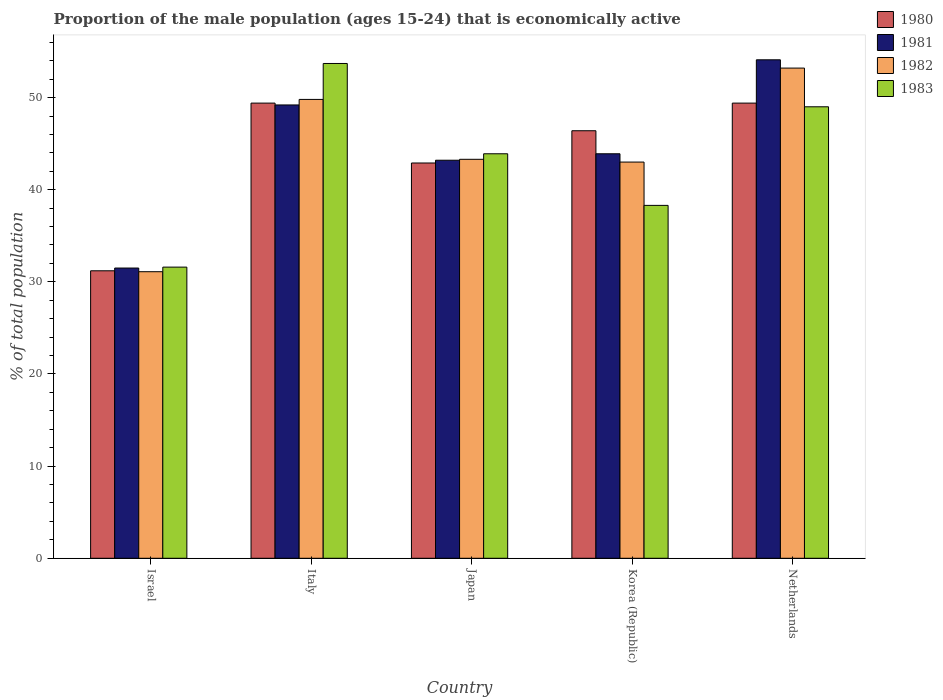Are the number of bars per tick equal to the number of legend labels?
Make the answer very short. Yes. How many bars are there on the 3rd tick from the right?
Offer a terse response. 4. In how many cases, is the number of bars for a given country not equal to the number of legend labels?
Your answer should be compact. 0. What is the proportion of the male population that is economically active in 1980 in Netherlands?
Ensure brevity in your answer.  49.4. Across all countries, what is the maximum proportion of the male population that is economically active in 1982?
Keep it short and to the point. 53.2. Across all countries, what is the minimum proportion of the male population that is economically active in 1981?
Provide a succinct answer. 31.5. In which country was the proportion of the male population that is economically active in 1982 minimum?
Give a very brief answer. Israel. What is the total proportion of the male population that is economically active in 1982 in the graph?
Provide a succinct answer. 220.4. What is the difference between the proportion of the male population that is economically active in 1981 in Israel and that in Japan?
Your answer should be very brief. -11.7. What is the difference between the proportion of the male population that is economically active in 1982 in Israel and the proportion of the male population that is economically active in 1981 in Netherlands?
Your answer should be compact. -23. What is the average proportion of the male population that is economically active in 1980 per country?
Ensure brevity in your answer.  43.86. What is the difference between the proportion of the male population that is economically active of/in 1981 and proportion of the male population that is economically active of/in 1980 in Italy?
Keep it short and to the point. -0.2. What is the ratio of the proportion of the male population that is economically active in 1982 in Japan to that in Netherlands?
Your response must be concise. 0.81. What is the difference between the highest and the second highest proportion of the male population that is economically active in 1982?
Offer a terse response. 6.5. What is the difference between the highest and the lowest proportion of the male population that is economically active in 1980?
Offer a terse response. 18.2. In how many countries, is the proportion of the male population that is economically active in 1981 greater than the average proportion of the male population that is economically active in 1981 taken over all countries?
Your answer should be very brief. 2. What does the 2nd bar from the right in Israel represents?
Provide a short and direct response. 1982. Is it the case that in every country, the sum of the proportion of the male population that is economically active in 1982 and proportion of the male population that is economically active in 1980 is greater than the proportion of the male population that is economically active in 1983?
Give a very brief answer. Yes. How many bars are there?
Provide a succinct answer. 20. Are all the bars in the graph horizontal?
Offer a very short reply. No. Does the graph contain any zero values?
Your answer should be very brief. No. Where does the legend appear in the graph?
Provide a succinct answer. Top right. How many legend labels are there?
Give a very brief answer. 4. What is the title of the graph?
Give a very brief answer. Proportion of the male population (ages 15-24) that is economically active. What is the label or title of the X-axis?
Your answer should be very brief. Country. What is the label or title of the Y-axis?
Your answer should be very brief. % of total population. What is the % of total population in 1980 in Israel?
Provide a succinct answer. 31.2. What is the % of total population in 1981 in Israel?
Make the answer very short. 31.5. What is the % of total population in 1982 in Israel?
Give a very brief answer. 31.1. What is the % of total population in 1983 in Israel?
Your answer should be compact. 31.6. What is the % of total population in 1980 in Italy?
Offer a very short reply. 49.4. What is the % of total population in 1981 in Italy?
Make the answer very short. 49.2. What is the % of total population in 1982 in Italy?
Keep it short and to the point. 49.8. What is the % of total population of 1983 in Italy?
Provide a short and direct response. 53.7. What is the % of total population in 1980 in Japan?
Offer a terse response. 42.9. What is the % of total population of 1981 in Japan?
Ensure brevity in your answer.  43.2. What is the % of total population in 1982 in Japan?
Give a very brief answer. 43.3. What is the % of total population of 1983 in Japan?
Ensure brevity in your answer.  43.9. What is the % of total population of 1980 in Korea (Republic)?
Provide a short and direct response. 46.4. What is the % of total population of 1981 in Korea (Republic)?
Your response must be concise. 43.9. What is the % of total population in 1982 in Korea (Republic)?
Provide a succinct answer. 43. What is the % of total population in 1983 in Korea (Republic)?
Your answer should be very brief. 38.3. What is the % of total population in 1980 in Netherlands?
Make the answer very short. 49.4. What is the % of total population in 1981 in Netherlands?
Give a very brief answer. 54.1. What is the % of total population in 1982 in Netherlands?
Ensure brevity in your answer.  53.2. Across all countries, what is the maximum % of total population of 1980?
Your answer should be compact. 49.4. Across all countries, what is the maximum % of total population of 1981?
Your answer should be very brief. 54.1. Across all countries, what is the maximum % of total population in 1982?
Your response must be concise. 53.2. Across all countries, what is the maximum % of total population of 1983?
Your answer should be compact. 53.7. Across all countries, what is the minimum % of total population of 1980?
Your response must be concise. 31.2. Across all countries, what is the minimum % of total population in 1981?
Offer a very short reply. 31.5. Across all countries, what is the minimum % of total population of 1982?
Your response must be concise. 31.1. Across all countries, what is the minimum % of total population of 1983?
Make the answer very short. 31.6. What is the total % of total population in 1980 in the graph?
Give a very brief answer. 219.3. What is the total % of total population of 1981 in the graph?
Ensure brevity in your answer.  221.9. What is the total % of total population of 1982 in the graph?
Ensure brevity in your answer.  220.4. What is the total % of total population in 1983 in the graph?
Offer a terse response. 216.5. What is the difference between the % of total population in 1980 in Israel and that in Italy?
Give a very brief answer. -18.2. What is the difference between the % of total population of 1981 in Israel and that in Italy?
Provide a succinct answer. -17.7. What is the difference between the % of total population in 1982 in Israel and that in Italy?
Ensure brevity in your answer.  -18.7. What is the difference between the % of total population of 1983 in Israel and that in Italy?
Give a very brief answer. -22.1. What is the difference between the % of total population in 1981 in Israel and that in Japan?
Keep it short and to the point. -11.7. What is the difference between the % of total population in 1983 in Israel and that in Japan?
Ensure brevity in your answer.  -12.3. What is the difference between the % of total population in 1980 in Israel and that in Korea (Republic)?
Provide a succinct answer. -15.2. What is the difference between the % of total population in 1981 in Israel and that in Korea (Republic)?
Ensure brevity in your answer.  -12.4. What is the difference between the % of total population of 1980 in Israel and that in Netherlands?
Offer a very short reply. -18.2. What is the difference between the % of total population of 1981 in Israel and that in Netherlands?
Your response must be concise. -22.6. What is the difference between the % of total population of 1982 in Israel and that in Netherlands?
Ensure brevity in your answer.  -22.1. What is the difference between the % of total population of 1983 in Israel and that in Netherlands?
Provide a short and direct response. -17.4. What is the difference between the % of total population of 1982 in Italy and that in Japan?
Your response must be concise. 6.5. What is the difference between the % of total population of 1983 in Italy and that in Japan?
Your response must be concise. 9.8. What is the difference between the % of total population in 1980 in Italy and that in Korea (Republic)?
Make the answer very short. 3. What is the difference between the % of total population of 1981 in Italy and that in Korea (Republic)?
Provide a short and direct response. 5.3. What is the difference between the % of total population of 1983 in Italy and that in Korea (Republic)?
Your response must be concise. 15.4. What is the difference between the % of total population of 1980 in Italy and that in Netherlands?
Ensure brevity in your answer.  0. What is the difference between the % of total population of 1983 in Italy and that in Netherlands?
Offer a very short reply. 4.7. What is the difference between the % of total population in 1980 in Japan and that in Korea (Republic)?
Ensure brevity in your answer.  -3.5. What is the difference between the % of total population in 1981 in Japan and that in Korea (Republic)?
Your answer should be compact. -0.7. What is the difference between the % of total population in 1983 in Japan and that in Korea (Republic)?
Provide a short and direct response. 5.6. What is the difference between the % of total population in 1981 in Japan and that in Netherlands?
Offer a terse response. -10.9. What is the difference between the % of total population of 1982 in Japan and that in Netherlands?
Give a very brief answer. -9.9. What is the difference between the % of total population in 1983 in Japan and that in Netherlands?
Ensure brevity in your answer.  -5.1. What is the difference between the % of total population in 1981 in Korea (Republic) and that in Netherlands?
Keep it short and to the point. -10.2. What is the difference between the % of total population in 1982 in Korea (Republic) and that in Netherlands?
Your response must be concise. -10.2. What is the difference between the % of total population of 1980 in Israel and the % of total population of 1982 in Italy?
Provide a succinct answer. -18.6. What is the difference between the % of total population in 1980 in Israel and the % of total population in 1983 in Italy?
Your answer should be very brief. -22.5. What is the difference between the % of total population of 1981 in Israel and the % of total population of 1982 in Italy?
Ensure brevity in your answer.  -18.3. What is the difference between the % of total population in 1981 in Israel and the % of total population in 1983 in Italy?
Your response must be concise. -22.2. What is the difference between the % of total population of 1982 in Israel and the % of total population of 1983 in Italy?
Make the answer very short. -22.6. What is the difference between the % of total population of 1980 in Israel and the % of total population of 1981 in Japan?
Ensure brevity in your answer.  -12. What is the difference between the % of total population of 1980 in Israel and the % of total population of 1983 in Japan?
Your response must be concise. -12.7. What is the difference between the % of total population in 1981 in Israel and the % of total population in 1982 in Japan?
Your answer should be very brief. -11.8. What is the difference between the % of total population of 1981 in Israel and the % of total population of 1983 in Japan?
Your answer should be compact. -12.4. What is the difference between the % of total population of 1980 in Israel and the % of total population of 1981 in Korea (Republic)?
Ensure brevity in your answer.  -12.7. What is the difference between the % of total population of 1980 in Israel and the % of total population of 1983 in Korea (Republic)?
Your response must be concise. -7.1. What is the difference between the % of total population in 1981 in Israel and the % of total population in 1982 in Korea (Republic)?
Keep it short and to the point. -11.5. What is the difference between the % of total population of 1981 in Israel and the % of total population of 1983 in Korea (Republic)?
Ensure brevity in your answer.  -6.8. What is the difference between the % of total population of 1980 in Israel and the % of total population of 1981 in Netherlands?
Provide a short and direct response. -22.9. What is the difference between the % of total population of 1980 in Israel and the % of total population of 1982 in Netherlands?
Give a very brief answer. -22. What is the difference between the % of total population of 1980 in Israel and the % of total population of 1983 in Netherlands?
Your response must be concise. -17.8. What is the difference between the % of total population of 1981 in Israel and the % of total population of 1982 in Netherlands?
Make the answer very short. -21.7. What is the difference between the % of total population in 1981 in Israel and the % of total population in 1983 in Netherlands?
Provide a succinct answer. -17.5. What is the difference between the % of total population of 1982 in Israel and the % of total population of 1983 in Netherlands?
Your answer should be very brief. -17.9. What is the difference between the % of total population of 1980 in Italy and the % of total population of 1981 in Japan?
Give a very brief answer. 6.2. What is the difference between the % of total population in 1981 in Italy and the % of total population in 1982 in Japan?
Provide a succinct answer. 5.9. What is the difference between the % of total population in 1980 in Italy and the % of total population in 1981 in Korea (Republic)?
Offer a terse response. 5.5. What is the difference between the % of total population in 1980 in Italy and the % of total population in 1982 in Korea (Republic)?
Make the answer very short. 6.4. What is the difference between the % of total population of 1980 in Italy and the % of total population of 1983 in Korea (Republic)?
Give a very brief answer. 11.1. What is the difference between the % of total population in 1981 in Italy and the % of total population in 1982 in Korea (Republic)?
Your answer should be compact. 6.2. What is the difference between the % of total population of 1981 in Italy and the % of total population of 1983 in Korea (Republic)?
Offer a very short reply. 10.9. What is the difference between the % of total population of 1980 in Italy and the % of total population of 1981 in Netherlands?
Offer a terse response. -4.7. What is the difference between the % of total population of 1980 in Italy and the % of total population of 1982 in Netherlands?
Make the answer very short. -3.8. What is the difference between the % of total population in 1980 in Italy and the % of total population in 1983 in Netherlands?
Ensure brevity in your answer.  0.4. What is the difference between the % of total population of 1981 in Italy and the % of total population of 1982 in Netherlands?
Your response must be concise. -4. What is the difference between the % of total population in 1981 in Italy and the % of total population in 1983 in Netherlands?
Provide a succinct answer. 0.2. What is the difference between the % of total population of 1982 in Italy and the % of total population of 1983 in Netherlands?
Your answer should be very brief. 0.8. What is the difference between the % of total population of 1980 in Japan and the % of total population of 1982 in Korea (Republic)?
Offer a very short reply. -0.1. What is the difference between the % of total population in 1981 in Japan and the % of total population in 1982 in Korea (Republic)?
Provide a succinct answer. 0.2. What is the difference between the % of total population in 1981 in Japan and the % of total population in 1983 in Korea (Republic)?
Your answer should be compact. 4.9. What is the difference between the % of total population of 1982 in Japan and the % of total population of 1983 in Korea (Republic)?
Your response must be concise. 5. What is the difference between the % of total population of 1980 in Japan and the % of total population of 1981 in Netherlands?
Your response must be concise. -11.2. What is the difference between the % of total population of 1980 in Japan and the % of total population of 1982 in Netherlands?
Offer a very short reply. -10.3. What is the difference between the % of total population in 1980 in Korea (Republic) and the % of total population in 1981 in Netherlands?
Your answer should be very brief. -7.7. What is the difference between the % of total population in 1980 in Korea (Republic) and the % of total population in 1982 in Netherlands?
Keep it short and to the point. -6.8. What is the average % of total population of 1980 per country?
Your answer should be very brief. 43.86. What is the average % of total population of 1981 per country?
Provide a short and direct response. 44.38. What is the average % of total population in 1982 per country?
Give a very brief answer. 44.08. What is the average % of total population of 1983 per country?
Provide a succinct answer. 43.3. What is the difference between the % of total population of 1980 and % of total population of 1981 in Israel?
Give a very brief answer. -0.3. What is the difference between the % of total population in 1980 and % of total population in 1983 in Israel?
Give a very brief answer. -0.4. What is the difference between the % of total population in 1981 and % of total population in 1982 in Israel?
Offer a terse response. 0.4. What is the difference between the % of total population in 1981 and % of total population in 1983 in Israel?
Your response must be concise. -0.1. What is the difference between the % of total population of 1982 and % of total population of 1983 in Israel?
Offer a terse response. -0.5. What is the difference between the % of total population in 1980 and % of total population in 1981 in Italy?
Give a very brief answer. 0.2. What is the difference between the % of total population in 1980 and % of total population in 1982 in Italy?
Your response must be concise. -0.4. What is the difference between the % of total population in 1981 and % of total population in 1982 in Italy?
Your answer should be compact. -0.6. What is the difference between the % of total population in 1980 and % of total population in 1981 in Japan?
Your answer should be compact. -0.3. What is the difference between the % of total population of 1981 and % of total population of 1982 in Japan?
Offer a very short reply. -0.1. What is the difference between the % of total population of 1982 and % of total population of 1983 in Japan?
Offer a terse response. -0.6. What is the difference between the % of total population in 1980 and % of total population in 1981 in Korea (Republic)?
Your answer should be very brief. 2.5. What is the difference between the % of total population of 1980 and % of total population of 1982 in Korea (Republic)?
Keep it short and to the point. 3.4. What is the difference between the % of total population in 1981 and % of total population in 1982 in Korea (Republic)?
Your response must be concise. 0.9. What is the difference between the % of total population in 1982 and % of total population in 1983 in Korea (Republic)?
Your response must be concise. 4.7. What is the difference between the % of total population in 1980 and % of total population in 1982 in Netherlands?
Ensure brevity in your answer.  -3.8. What is the difference between the % of total population of 1981 and % of total population of 1983 in Netherlands?
Keep it short and to the point. 5.1. What is the difference between the % of total population in 1982 and % of total population in 1983 in Netherlands?
Provide a short and direct response. 4.2. What is the ratio of the % of total population of 1980 in Israel to that in Italy?
Provide a short and direct response. 0.63. What is the ratio of the % of total population of 1981 in Israel to that in Italy?
Make the answer very short. 0.64. What is the ratio of the % of total population of 1982 in Israel to that in Italy?
Offer a terse response. 0.62. What is the ratio of the % of total population in 1983 in Israel to that in Italy?
Offer a very short reply. 0.59. What is the ratio of the % of total population of 1980 in Israel to that in Japan?
Offer a terse response. 0.73. What is the ratio of the % of total population of 1981 in Israel to that in Japan?
Ensure brevity in your answer.  0.73. What is the ratio of the % of total population in 1982 in Israel to that in Japan?
Provide a succinct answer. 0.72. What is the ratio of the % of total population of 1983 in Israel to that in Japan?
Give a very brief answer. 0.72. What is the ratio of the % of total population in 1980 in Israel to that in Korea (Republic)?
Offer a very short reply. 0.67. What is the ratio of the % of total population in 1981 in Israel to that in Korea (Republic)?
Offer a terse response. 0.72. What is the ratio of the % of total population of 1982 in Israel to that in Korea (Republic)?
Provide a succinct answer. 0.72. What is the ratio of the % of total population in 1983 in Israel to that in Korea (Republic)?
Keep it short and to the point. 0.83. What is the ratio of the % of total population in 1980 in Israel to that in Netherlands?
Provide a short and direct response. 0.63. What is the ratio of the % of total population of 1981 in Israel to that in Netherlands?
Make the answer very short. 0.58. What is the ratio of the % of total population in 1982 in Israel to that in Netherlands?
Provide a succinct answer. 0.58. What is the ratio of the % of total population in 1983 in Israel to that in Netherlands?
Your answer should be compact. 0.64. What is the ratio of the % of total population of 1980 in Italy to that in Japan?
Your response must be concise. 1.15. What is the ratio of the % of total population in 1981 in Italy to that in Japan?
Keep it short and to the point. 1.14. What is the ratio of the % of total population of 1982 in Italy to that in Japan?
Your answer should be compact. 1.15. What is the ratio of the % of total population of 1983 in Italy to that in Japan?
Give a very brief answer. 1.22. What is the ratio of the % of total population in 1980 in Italy to that in Korea (Republic)?
Offer a very short reply. 1.06. What is the ratio of the % of total population of 1981 in Italy to that in Korea (Republic)?
Offer a very short reply. 1.12. What is the ratio of the % of total population in 1982 in Italy to that in Korea (Republic)?
Your response must be concise. 1.16. What is the ratio of the % of total population of 1983 in Italy to that in Korea (Republic)?
Your response must be concise. 1.4. What is the ratio of the % of total population of 1980 in Italy to that in Netherlands?
Your answer should be compact. 1. What is the ratio of the % of total population in 1981 in Italy to that in Netherlands?
Keep it short and to the point. 0.91. What is the ratio of the % of total population of 1982 in Italy to that in Netherlands?
Keep it short and to the point. 0.94. What is the ratio of the % of total population in 1983 in Italy to that in Netherlands?
Your answer should be very brief. 1.1. What is the ratio of the % of total population of 1980 in Japan to that in Korea (Republic)?
Ensure brevity in your answer.  0.92. What is the ratio of the % of total population in 1981 in Japan to that in Korea (Republic)?
Your response must be concise. 0.98. What is the ratio of the % of total population of 1983 in Japan to that in Korea (Republic)?
Provide a succinct answer. 1.15. What is the ratio of the % of total population in 1980 in Japan to that in Netherlands?
Your response must be concise. 0.87. What is the ratio of the % of total population in 1981 in Japan to that in Netherlands?
Give a very brief answer. 0.8. What is the ratio of the % of total population in 1982 in Japan to that in Netherlands?
Offer a terse response. 0.81. What is the ratio of the % of total population of 1983 in Japan to that in Netherlands?
Your response must be concise. 0.9. What is the ratio of the % of total population of 1980 in Korea (Republic) to that in Netherlands?
Give a very brief answer. 0.94. What is the ratio of the % of total population of 1981 in Korea (Republic) to that in Netherlands?
Your response must be concise. 0.81. What is the ratio of the % of total population in 1982 in Korea (Republic) to that in Netherlands?
Provide a short and direct response. 0.81. What is the ratio of the % of total population in 1983 in Korea (Republic) to that in Netherlands?
Your answer should be very brief. 0.78. What is the difference between the highest and the second highest % of total population of 1981?
Keep it short and to the point. 4.9. What is the difference between the highest and the lowest % of total population of 1981?
Offer a very short reply. 22.6. What is the difference between the highest and the lowest % of total population of 1982?
Your answer should be very brief. 22.1. What is the difference between the highest and the lowest % of total population of 1983?
Give a very brief answer. 22.1. 